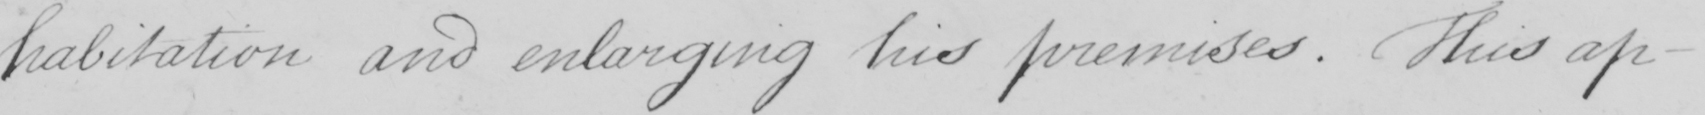Can you tell me what this handwritten text says? habitation and enlarging his premises . This ap- 